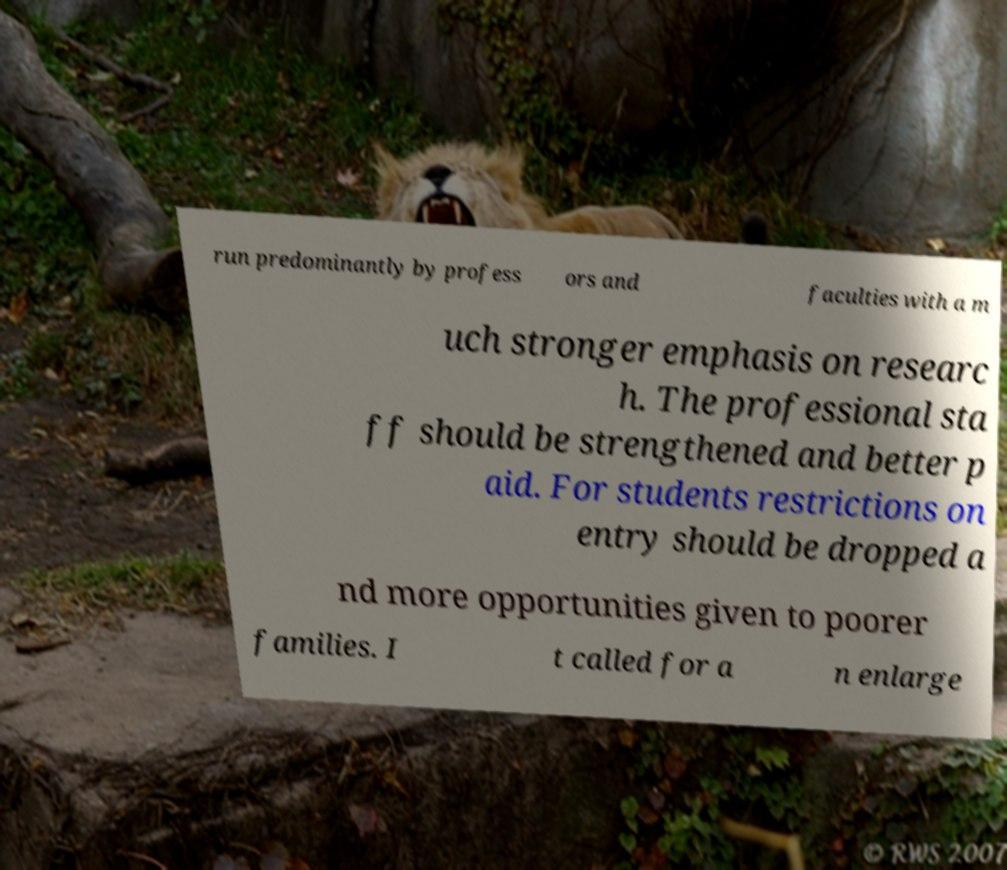For documentation purposes, I need the text within this image transcribed. Could you provide that? run predominantly by profess ors and faculties with a m uch stronger emphasis on researc h. The professional sta ff should be strengthened and better p aid. For students restrictions on entry should be dropped a nd more opportunities given to poorer families. I t called for a n enlarge 